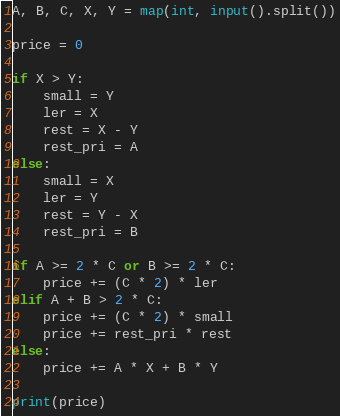<code> <loc_0><loc_0><loc_500><loc_500><_Python_>A, B, C, X, Y = map(int, input().split())

price = 0

if X > Y:
    small = Y
    ler = X
    rest = X - Y
    rest_pri = A
else:
    small = X
    ler = Y
    rest = Y - X
    rest_pri = B

if A >= 2 * C or B >= 2 * C:
    price += (C * 2) * ler
elif A + B > 2 * C:
    price += (C * 2) * small
    price += rest_pri * rest
else:
    price += A * X + B * Y

print(price)
</code> 